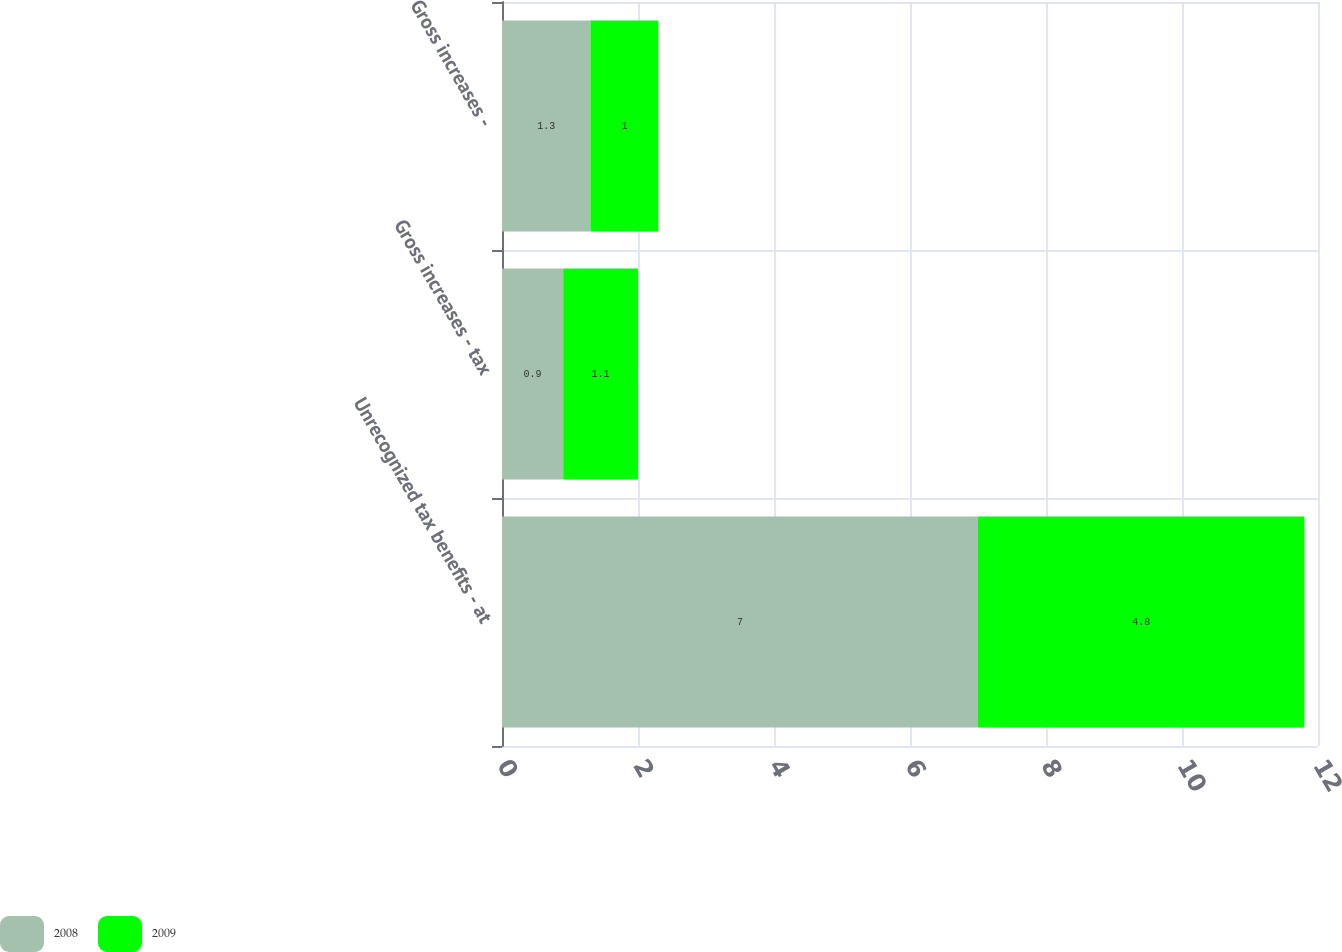<chart> <loc_0><loc_0><loc_500><loc_500><stacked_bar_chart><ecel><fcel>Unrecognized tax benefits - at<fcel>Gross increases - tax<fcel>Gross increases -<nl><fcel>2008<fcel>7<fcel>0.9<fcel>1.3<nl><fcel>2009<fcel>4.8<fcel>1.1<fcel>1<nl></chart> 